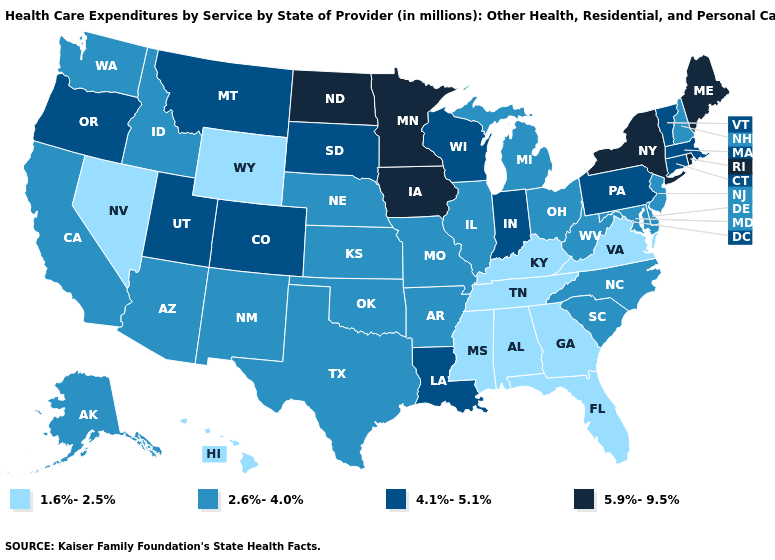Among the states that border Pennsylvania , which have the highest value?
Short answer required. New York. What is the highest value in the Northeast ?
Quick response, please. 5.9%-9.5%. What is the value of Massachusetts?
Write a very short answer. 4.1%-5.1%. Does Pennsylvania have a lower value than Minnesota?
Short answer required. Yes. Name the states that have a value in the range 5.9%-9.5%?
Concise answer only. Iowa, Maine, Minnesota, New York, North Dakota, Rhode Island. What is the value of Oregon?
Write a very short answer. 4.1%-5.1%. Which states have the lowest value in the USA?
Be succinct. Alabama, Florida, Georgia, Hawaii, Kentucky, Mississippi, Nevada, Tennessee, Virginia, Wyoming. What is the value of Pennsylvania?
Give a very brief answer. 4.1%-5.1%. What is the value of Indiana?
Write a very short answer. 4.1%-5.1%. What is the highest value in the West ?
Quick response, please. 4.1%-5.1%. What is the lowest value in states that border Oklahoma?
Keep it brief. 2.6%-4.0%. What is the value of Florida?
Give a very brief answer. 1.6%-2.5%. Name the states that have a value in the range 2.6%-4.0%?
Keep it brief. Alaska, Arizona, Arkansas, California, Delaware, Idaho, Illinois, Kansas, Maryland, Michigan, Missouri, Nebraska, New Hampshire, New Jersey, New Mexico, North Carolina, Ohio, Oklahoma, South Carolina, Texas, Washington, West Virginia. What is the lowest value in the West?
Give a very brief answer. 1.6%-2.5%. Does Louisiana have the lowest value in the South?
Keep it brief. No. 